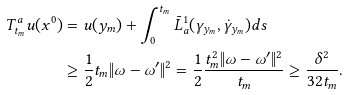Convert formula to latex. <formula><loc_0><loc_0><loc_500><loc_500>T ^ { a } _ { t _ { m } } u ( x ^ { 0 } ) & = u ( y _ { m } ) + \int _ { 0 } ^ { t _ { m } } \bar { L } ^ { 1 } _ { a } ( \gamma _ { y _ { m } } , \dot { \gamma } _ { y _ { m } } ) d s \\ & \geq \frac { 1 } { 2 } t _ { m } \| \omega - \omega ^ { \prime } \| ^ { 2 } = \frac { 1 } { 2 } \frac { t ^ { 2 } _ { m } \| \omega - \omega ^ { \prime } \| ^ { 2 } } { t _ { m } } \geq \frac { \delta ^ { 2 } } { 3 2 t _ { m } } .</formula> 